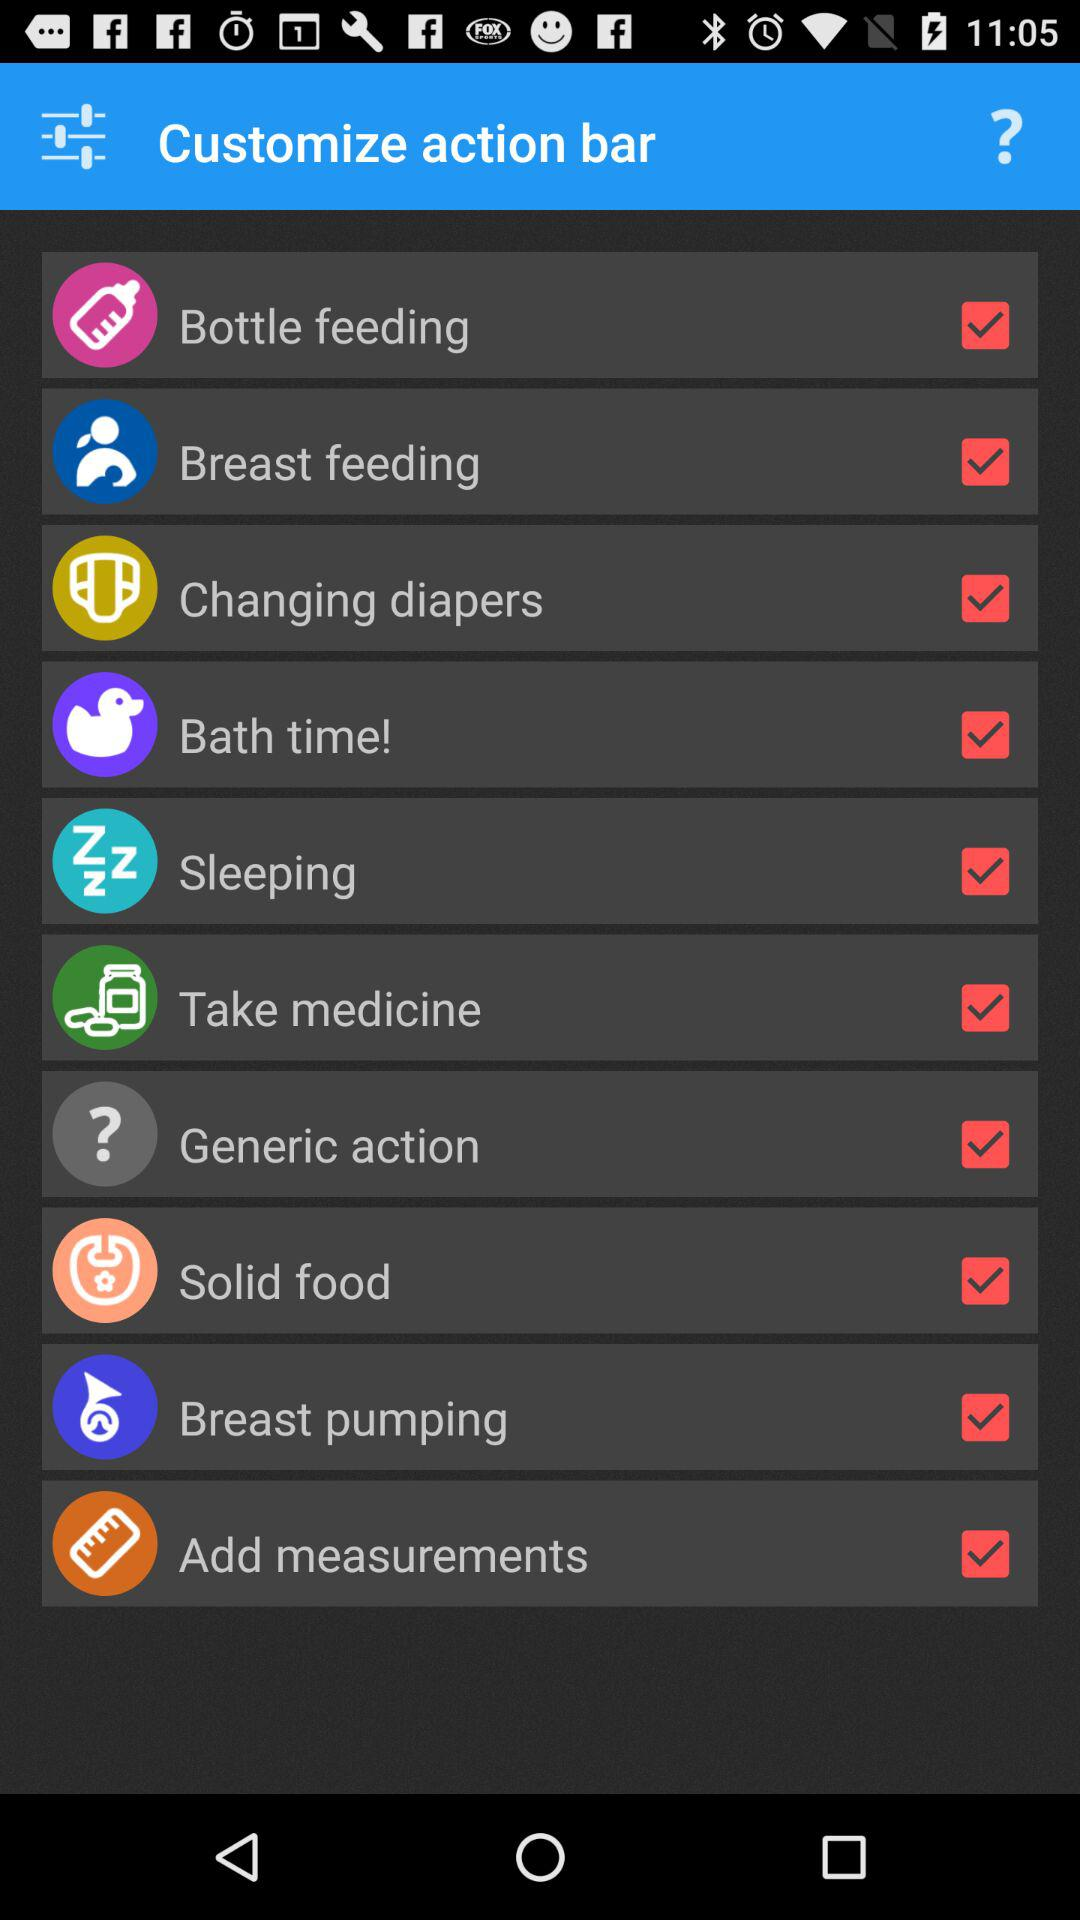What is the status of "Changing diapers"? The status is "on". 